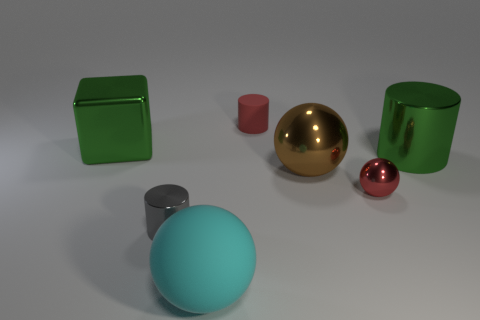How many large objects are left of the large rubber sphere and in front of the gray shiny object?
Your response must be concise. 0. How many other things are the same color as the small matte cylinder?
Provide a succinct answer. 1. There is a small gray object behind the cyan object; what shape is it?
Your answer should be compact. Cylinder. Do the big cyan thing and the green cylinder have the same material?
Offer a very short reply. No. How many big metal things are on the left side of the big brown metal object?
Offer a very short reply. 1. What shape is the matte object behind the green thing that is right of the small red rubber cylinder?
Your answer should be very brief. Cylinder. Are there any other things that are the same shape as the cyan rubber thing?
Offer a very short reply. Yes. Are there more large brown shiny objects behind the tiny ball than big gray metallic objects?
Provide a short and direct response. Yes. What number of large balls are on the left side of the matte object that is in front of the red metal sphere?
Make the answer very short. 0. The red thing that is behind the metallic thing behind the green object to the right of the green cube is what shape?
Keep it short and to the point. Cylinder. 